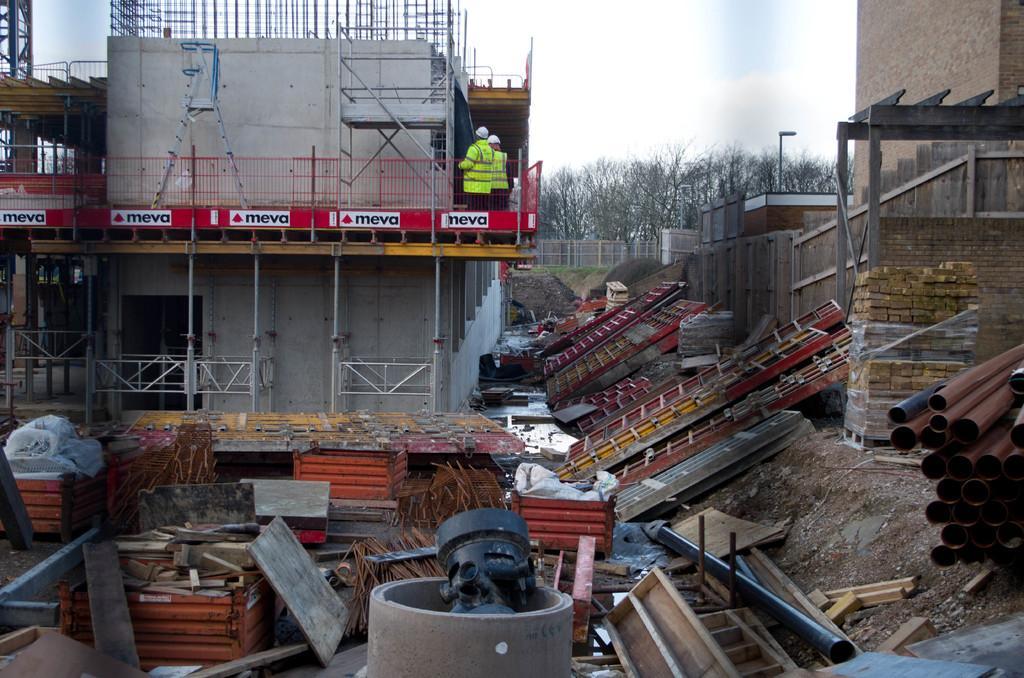Can you describe this image briefly? This is a building, which is under construction. These are the kind of barricades, which are red in color. I can see two people standing. These are the doors, iron pipes, wooden objects and few other materials. In the background, I can see the trees. On the right side of the image, I think this is a building wall. Here is the sky. 